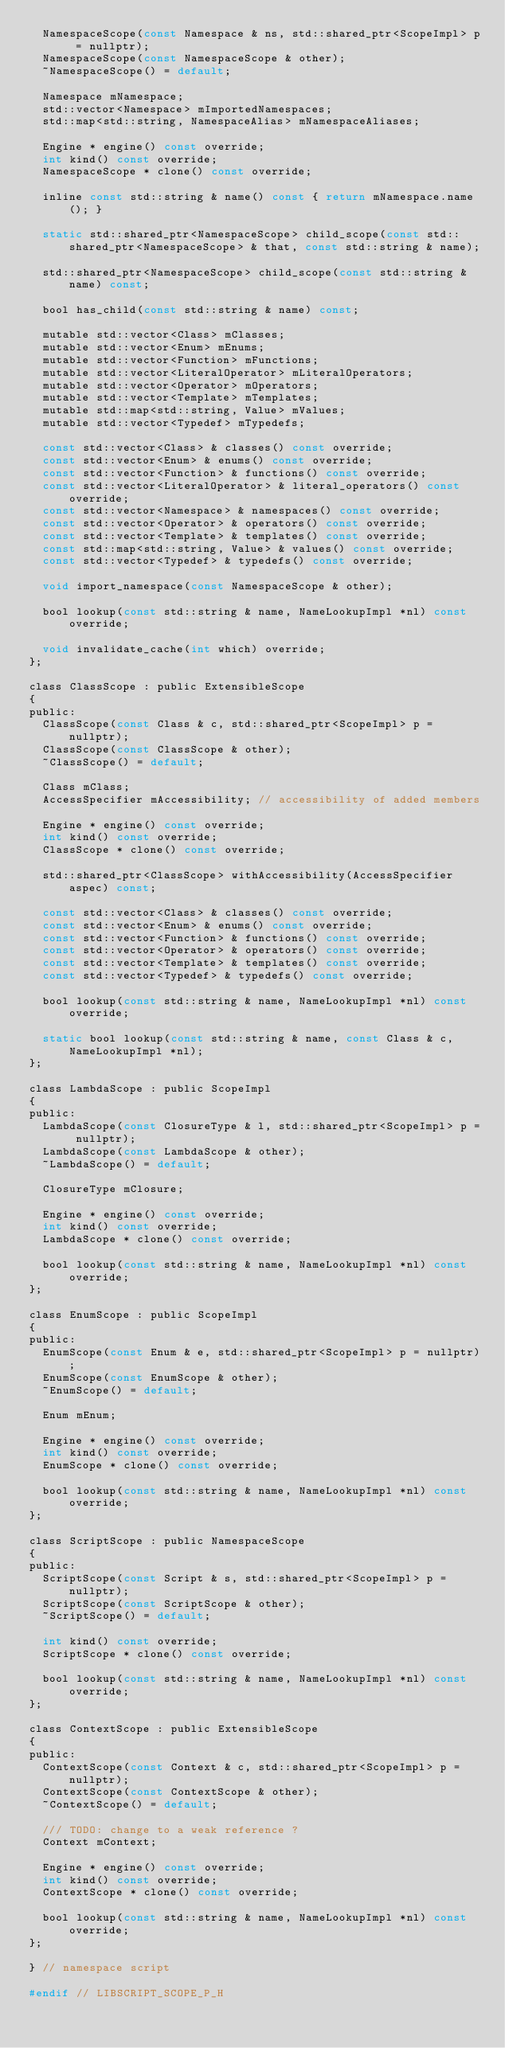<code> <loc_0><loc_0><loc_500><loc_500><_C_>  NamespaceScope(const Namespace & ns, std::shared_ptr<ScopeImpl> p = nullptr);
  NamespaceScope(const NamespaceScope & other);
  ~NamespaceScope() = default;

  Namespace mNamespace;
  std::vector<Namespace> mImportedNamespaces;
  std::map<std::string, NamespaceAlias> mNamespaceAliases;

  Engine * engine() const override;
  int kind() const override;
  NamespaceScope * clone() const override;

  inline const std::string & name() const { return mNamespace.name(); }

  static std::shared_ptr<NamespaceScope> child_scope(const std::shared_ptr<NamespaceScope> & that, const std::string & name);
 
  std::shared_ptr<NamespaceScope> child_scope(const std::string & name) const;

  bool has_child(const std::string & name) const;

  mutable std::vector<Class> mClasses;
  mutable std::vector<Enum> mEnums;
  mutable std::vector<Function> mFunctions;
  mutable std::vector<LiteralOperator> mLiteralOperators;
  mutable std::vector<Operator> mOperators;
  mutable std::vector<Template> mTemplates;
  mutable std::map<std::string, Value> mValues;
  mutable std::vector<Typedef> mTypedefs;

  const std::vector<Class> & classes() const override;
  const std::vector<Enum> & enums() const override;
  const std::vector<Function> & functions() const override;
  const std::vector<LiteralOperator> & literal_operators() const override;
  const std::vector<Namespace> & namespaces() const override;
  const std::vector<Operator> & operators() const override;
  const std::vector<Template> & templates() const override;
  const std::map<std::string, Value> & values() const override;
  const std::vector<Typedef> & typedefs() const override;

  void import_namespace(const NamespaceScope & other);

  bool lookup(const std::string & name, NameLookupImpl *nl) const override;

  void invalidate_cache(int which) override;
};

class ClassScope : public ExtensibleScope
{
public:
  ClassScope(const Class & c, std::shared_ptr<ScopeImpl> p = nullptr);
  ClassScope(const ClassScope & other);
  ~ClassScope() = default;

  Class mClass;
  AccessSpecifier mAccessibility; // accessibility of added members

  Engine * engine() const override;
  int kind() const override;
  ClassScope * clone() const override;

  std::shared_ptr<ClassScope> withAccessibility(AccessSpecifier aspec) const;

  const std::vector<Class> & classes() const override;
  const std::vector<Enum> & enums() const override;
  const std::vector<Function> & functions() const override;
  const std::vector<Operator> & operators() const override;
  const std::vector<Template> & templates() const override;
  const std::vector<Typedef> & typedefs() const override;

  bool lookup(const std::string & name, NameLookupImpl *nl) const override;

  static bool lookup(const std::string & name, const Class & c, NameLookupImpl *nl);
};

class LambdaScope : public ScopeImpl
{
public:
  LambdaScope(const ClosureType & l, std::shared_ptr<ScopeImpl> p = nullptr);
  LambdaScope(const LambdaScope & other);
  ~LambdaScope() = default;

  ClosureType mClosure;

  Engine * engine() const override;
  int kind() const override;
  LambdaScope * clone() const override;

  bool lookup(const std::string & name, NameLookupImpl *nl) const override;
};

class EnumScope : public ScopeImpl
{
public:
  EnumScope(const Enum & e, std::shared_ptr<ScopeImpl> p = nullptr);
  EnumScope(const EnumScope & other);
  ~EnumScope() = default;

  Enum mEnum;

  Engine * engine() const override;
  int kind() const override;
  EnumScope * clone() const override;

  bool lookup(const std::string & name, NameLookupImpl *nl) const override;
};

class ScriptScope : public NamespaceScope
{
public:
  ScriptScope(const Script & s, std::shared_ptr<ScopeImpl> p = nullptr);
  ScriptScope(const ScriptScope & other);
  ~ScriptScope() = default;

  int kind() const override;
  ScriptScope * clone() const override;

  bool lookup(const std::string & name, NameLookupImpl *nl) const override;
};

class ContextScope : public ExtensibleScope
{
public:
  ContextScope(const Context & c, std::shared_ptr<ScopeImpl> p = nullptr);
  ContextScope(const ContextScope & other);
  ~ContextScope() = default;

  /// TODO: change to a weak reference ?
  Context mContext;

  Engine * engine() const override;
  int kind() const override;
  ContextScope * clone() const override;

  bool lookup(const std::string & name, NameLookupImpl *nl) const override;
};

} // namespace script

#endif // LIBSCRIPT_SCOPE_P_H
</code> 